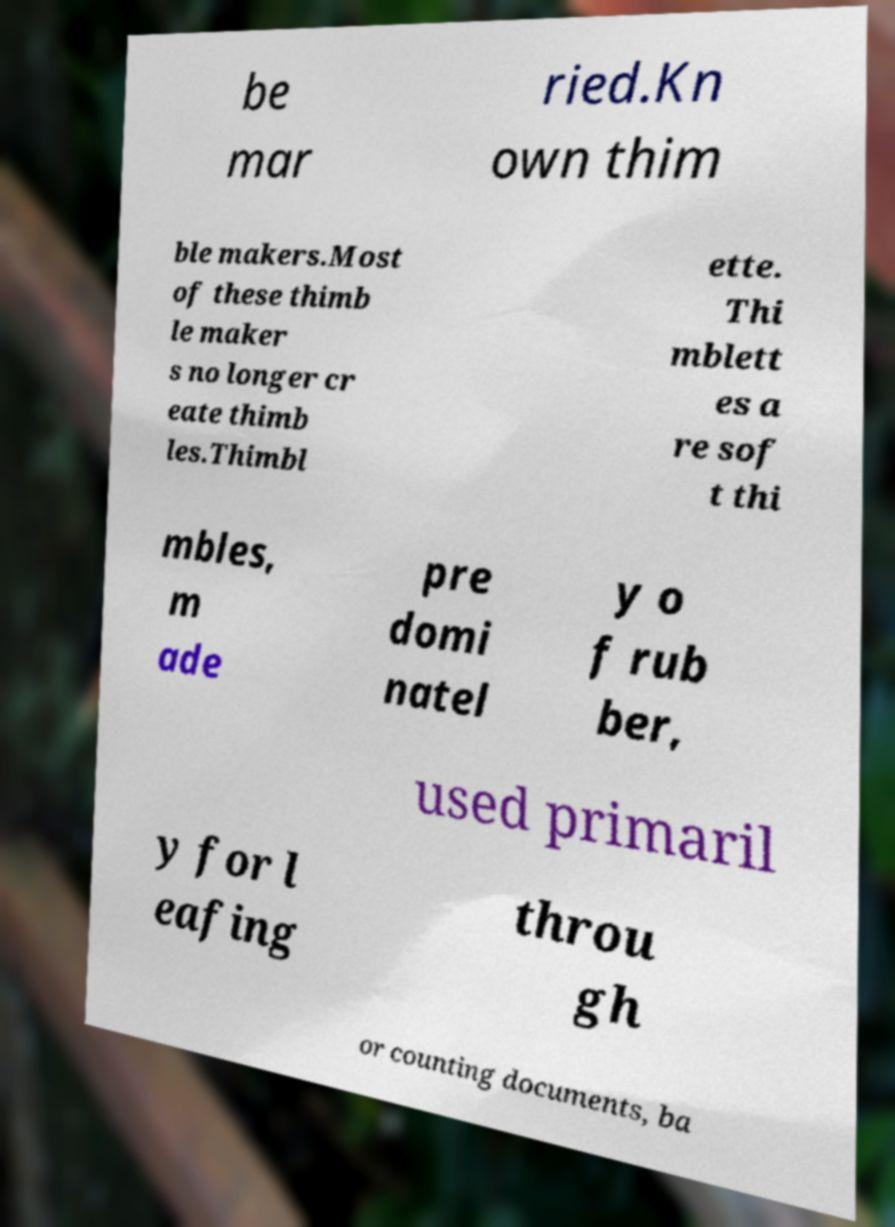Can you read and provide the text displayed in the image?This photo seems to have some interesting text. Can you extract and type it out for me? be mar ried.Kn own thim ble makers.Most of these thimb le maker s no longer cr eate thimb les.Thimbl ette. Thi mblett es a re sof t thi mbles, m ade pre domi natel y o f rub ber, used primaril y for l eafing throu gh or counting documents, ba 